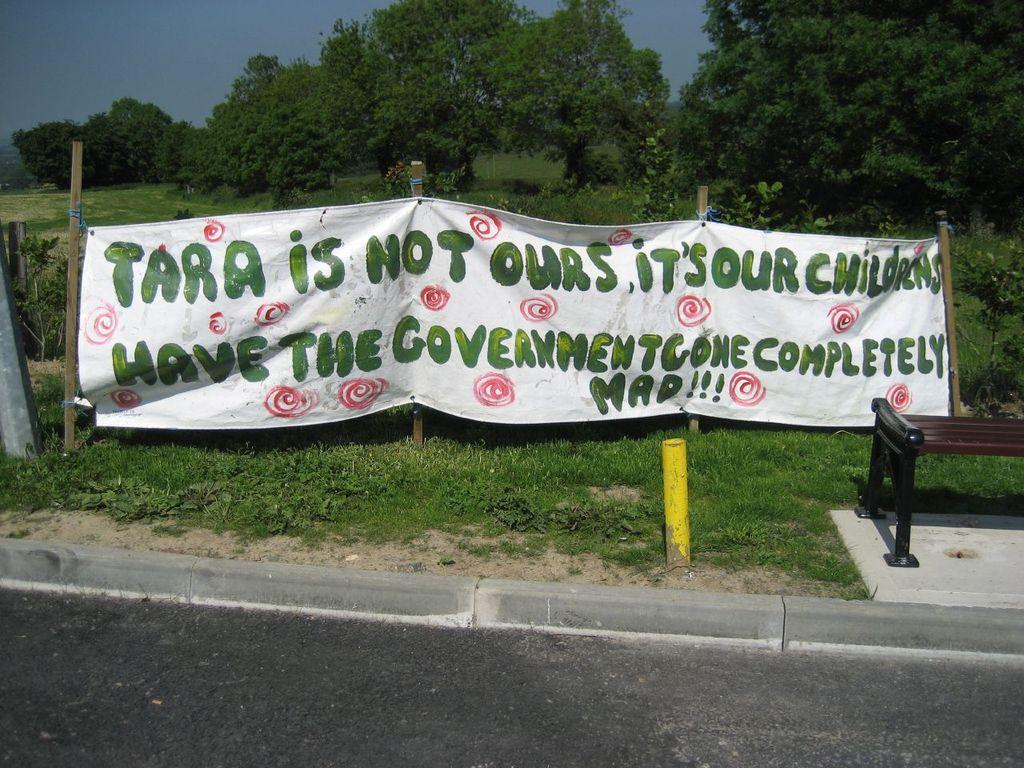What is present on the ground in the image? There is a banner and a bench on the ground in the image. What is the condition of the ground? The ground is covered with grass. What can be seen in the background of the image? There are trees in the background of the image. How does the growth of the trees affect the volcano in the image? There is no volcano present in the image, so the growth of the trees does not affect a volcano. 